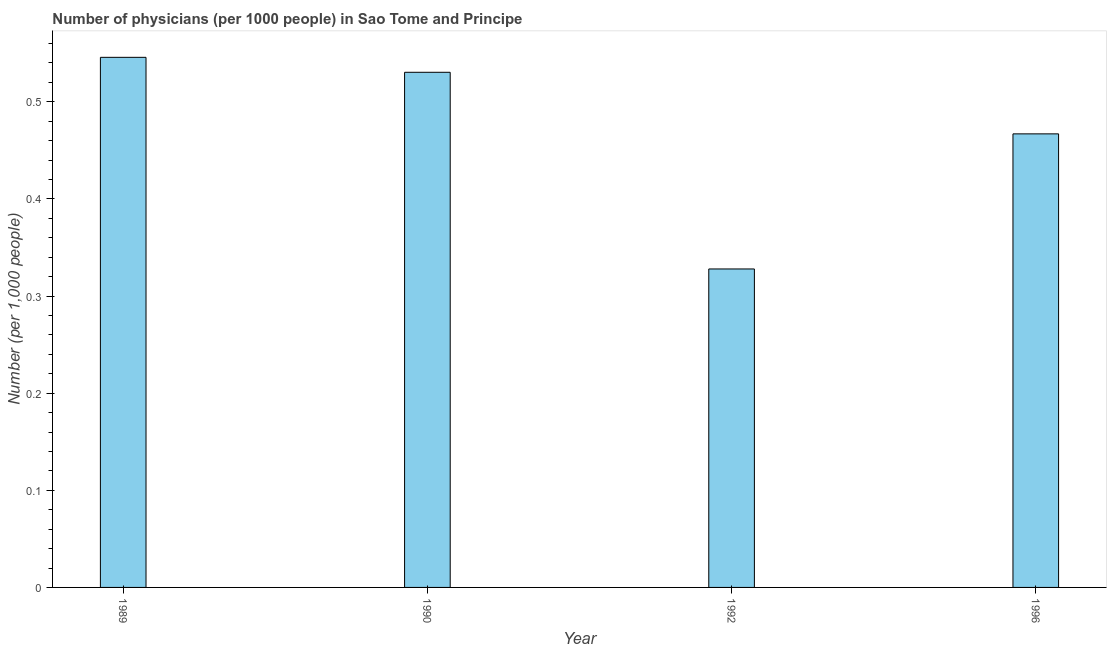Does the graph contain any zero values?
Your answer should be very brief. No. What is the title of the graph?
Make the answer very short. Number of physicians (per 1000 people) in Sao Tome and Principe. What is the label or title of the X-axis?
Your answer should be compact. Year. What is the label or title of the Y-axis?
Your answer should be compact. Number (per 1,0 people). What is the number of physicians in 1990?
Ensure brevity in your answer.  0.53. Across all years, what is the maximum number of physicians?
Offer a very short reply. 0.55. Across all years, what is the minimum number of physicians?
Provide a succinct answer. 0.33. What is the sum of the number of physicians?
Give a very brief answer. 1.87. What is the difference between the number of physicians in 1992 and 1996?
Your answer should be compact. -0.14. What is the average number of physicians per year?
Your answer should be compact. 0.47. What is the median number of physicians?
Make the answer very short. 0.5. Do a majority of the years between 1990 and 1992 (inclusive) have number of physicians greater than 0.38 ?
Your answer should be very brief. No. What is the ratio of the number of physicians in 1990 to that in 1996?
Ensure brevity in your answer.  1.14. What is the difference between the highest and the second highest number of physicians?
Offer a terse response. 0.01. What is the difference between the highest and the lowest number of physicians?
Offer a very short reply. 0.22. Are all the bars in the graph horizontal?
Provide a succinct answer. No. What is the Number (per 1,000 people) of 1989?
Ensure brevity in your answer.  0.55. What is the Number (per 1,000 people) of 1990?
Ensure brevity in your answer.  0.53. What is the Number (per 1,000 people) in 1992?
Your response must be concise. 0.33. What is the Number (per 1,000 people) in 1996?
Offer a very short reply. 0.47. What is the difference between the Number (per 1,000 people) in 1989 and 1990?
Offer a very short reply. 0.02. What is the difference between the Number (per 1,000 people) in 1989 and 1992?
Make the answer very short. 0.22. What is the difference between the Number (per 1,000 people) in 1989 and 1996?
Provide a short and direct response. 0.08. What is the difference between the Number (per 1,000 people) in 1990 and 1992?
Make the answer very short. 0.2. What is the difference between the Number (per 1,000 people) in 1990 and 1996?
Offer a very short reply. 0.06. What is the difference between the Number (per 1,000 people) in 1992 and 1996?
Offer a terse response. -0.14. What is the ratio of the Number (per 1,000 people) in 1989 to that in 1990?
Provide a succinct answer. 1.03. What is the ratio of the Number (per 1,000 people) in 1989 to that in 1992?
Your answer should be very brief. 1.67. What is the ratio of the Number (per 1,000 people) in 1989 to that in 1996?
Offer a very short reply. 1.17. What is the ratio of the Number (per 1,000 people) in 1990 to that in 1992?
Provide a succinct answer. 1.62. What is the ratio of the Number (per 1,000 people) in 1990 to that in 1996?
Give a very brief answer. 1.14. What is the ratio of the Number (per 1,000 people) in 1992 to that in 1996?
Your answer should be compact. 0.7. 